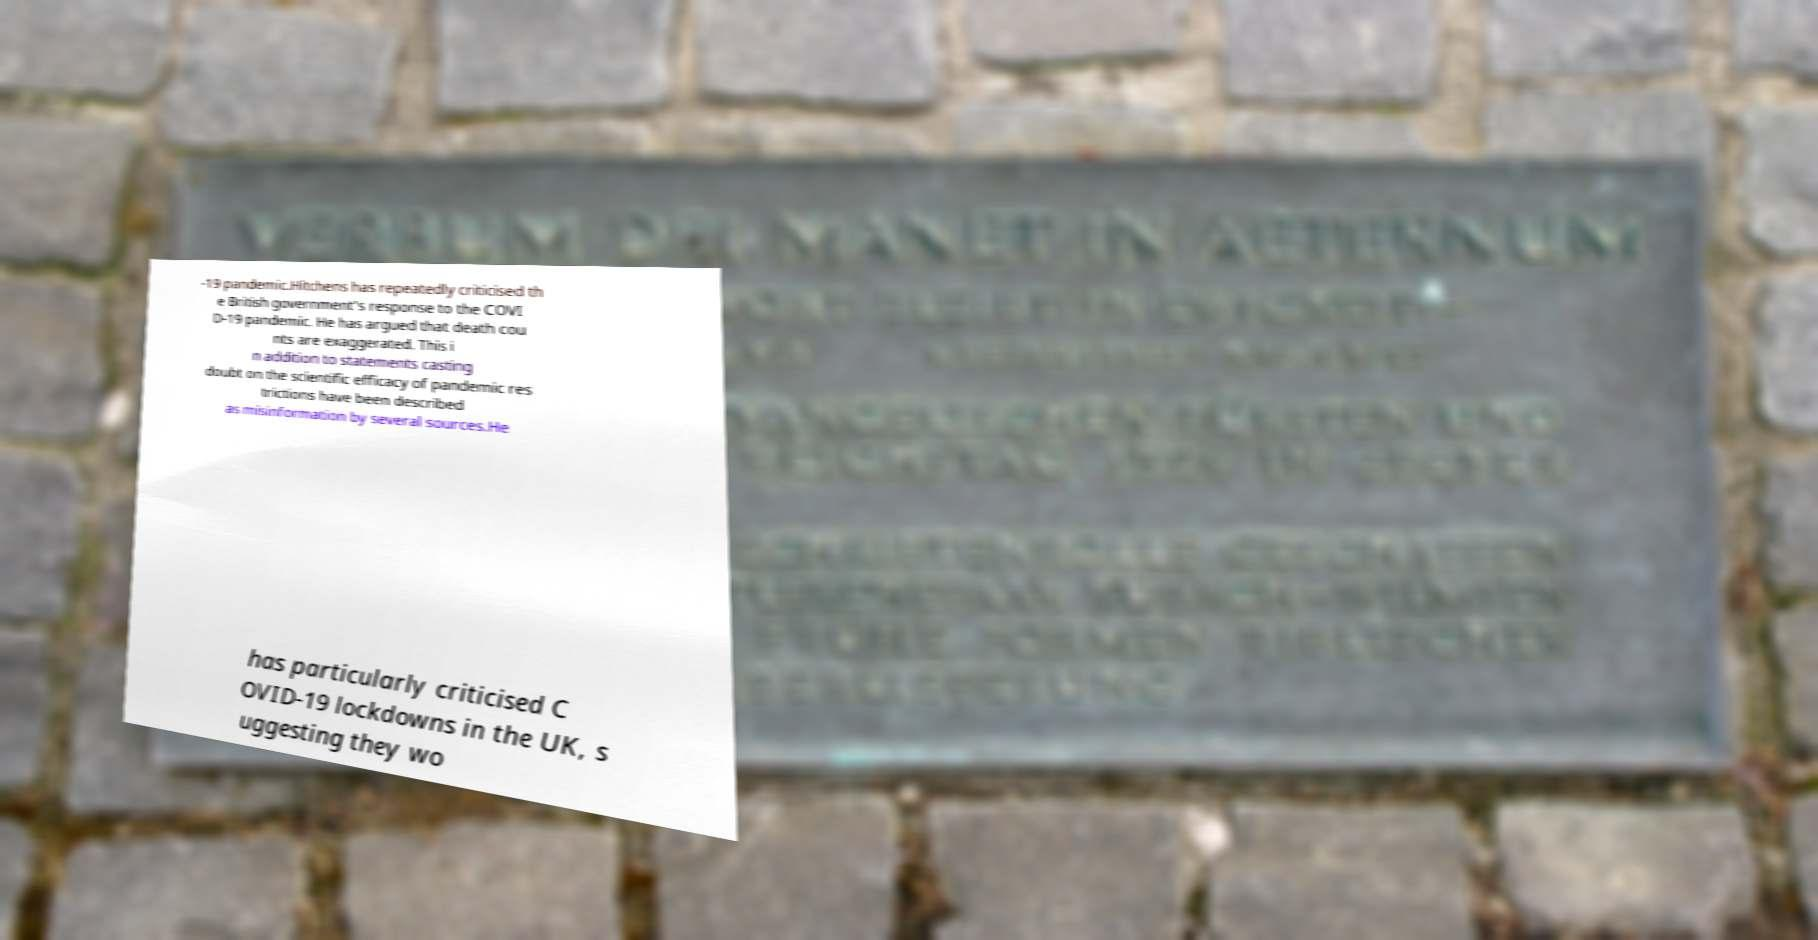What messages or text are displayed in this image? I need them in a readable, typed format. -19 pandemic.Hitchens has repeatedly criticised th e British government's response to the COVI D-19 pandemic. He has argued that death cou nts are exaggerated. This i n addition to statements casting doubt on the scientific efficacy of pandemic res trictions have been described as misinformation by several sources.He has particularly criticised C OVID-19 lockdowns in the UK, s uggesting they wo 